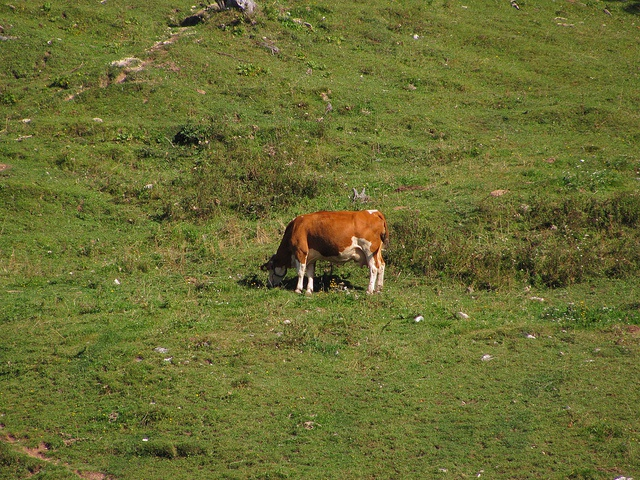Describe the objects in this image and their specific colors. I can see a cow in darkgreen, brown, black, maroon, and red tones in this image. 